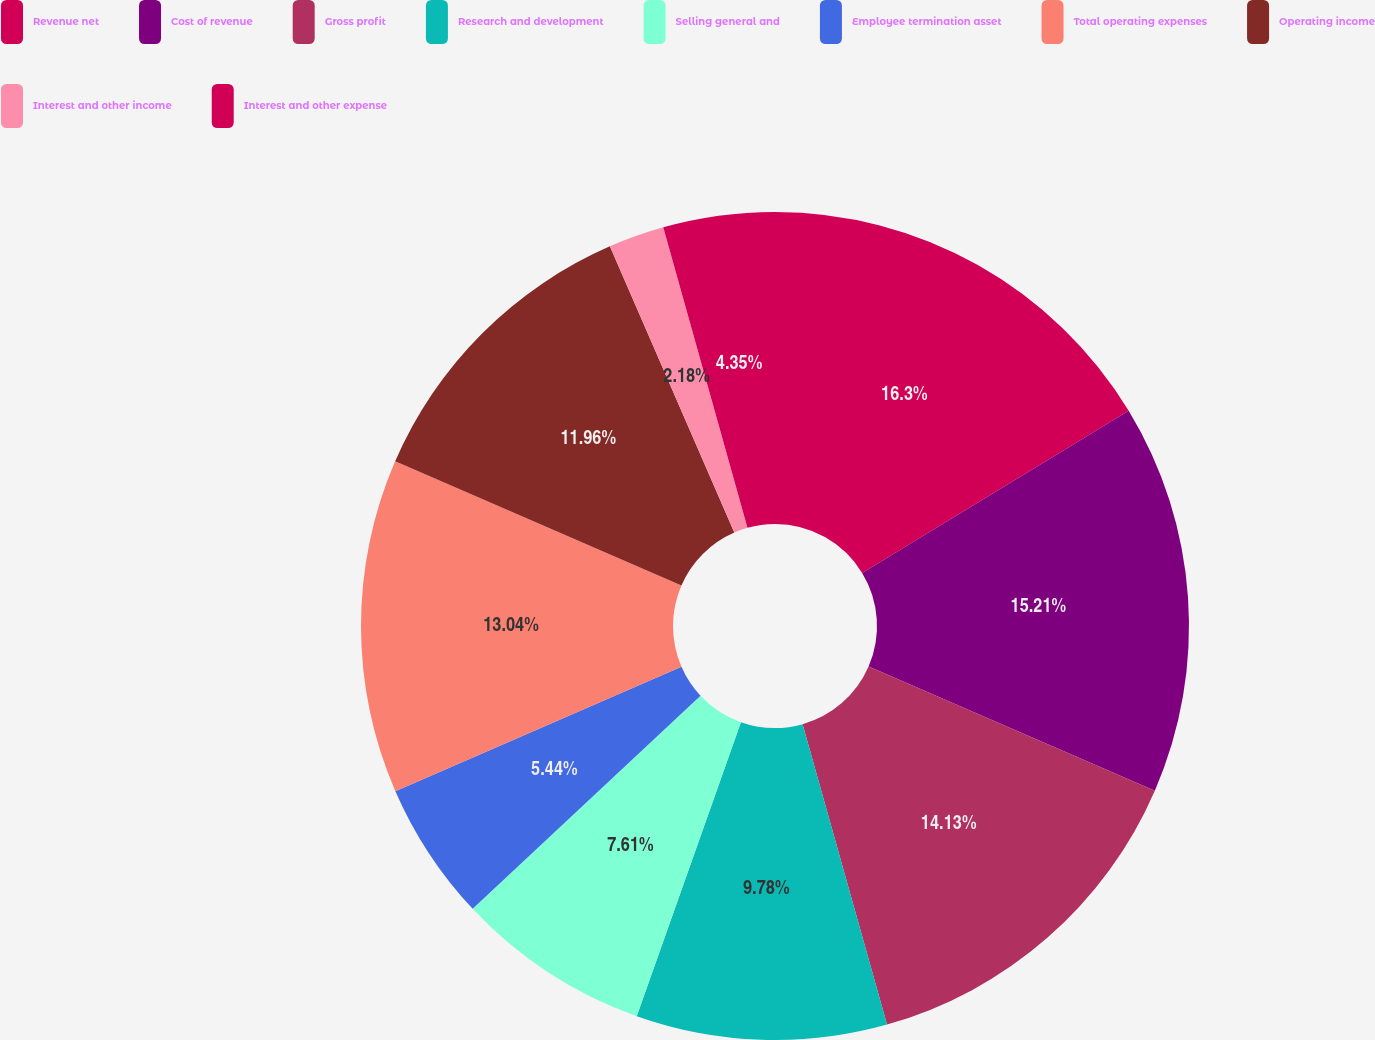Convert chart. <chart><loc_0><loc_0><loc_500><loc_500><pie_chart><fcel>Revenue net<fcel>Cost of revenue<fcel>Gross profit<fcel>Research and development<fcel>Selling general and<fcel>Employee termination asset<fcel>Total operating expenses<fcel>Operating income<fcel>Interest and other income<fcel>Interest and other expense<nl><fcel>16.3%<fcel>15.21%<fcel>14.13%<fcel>9.78%<fcel>7.61%<fcel>5.44%<fcel>13.04%<fcel>11.96%<fcel>2.18%<fcel>4.35%<nl></chart> 